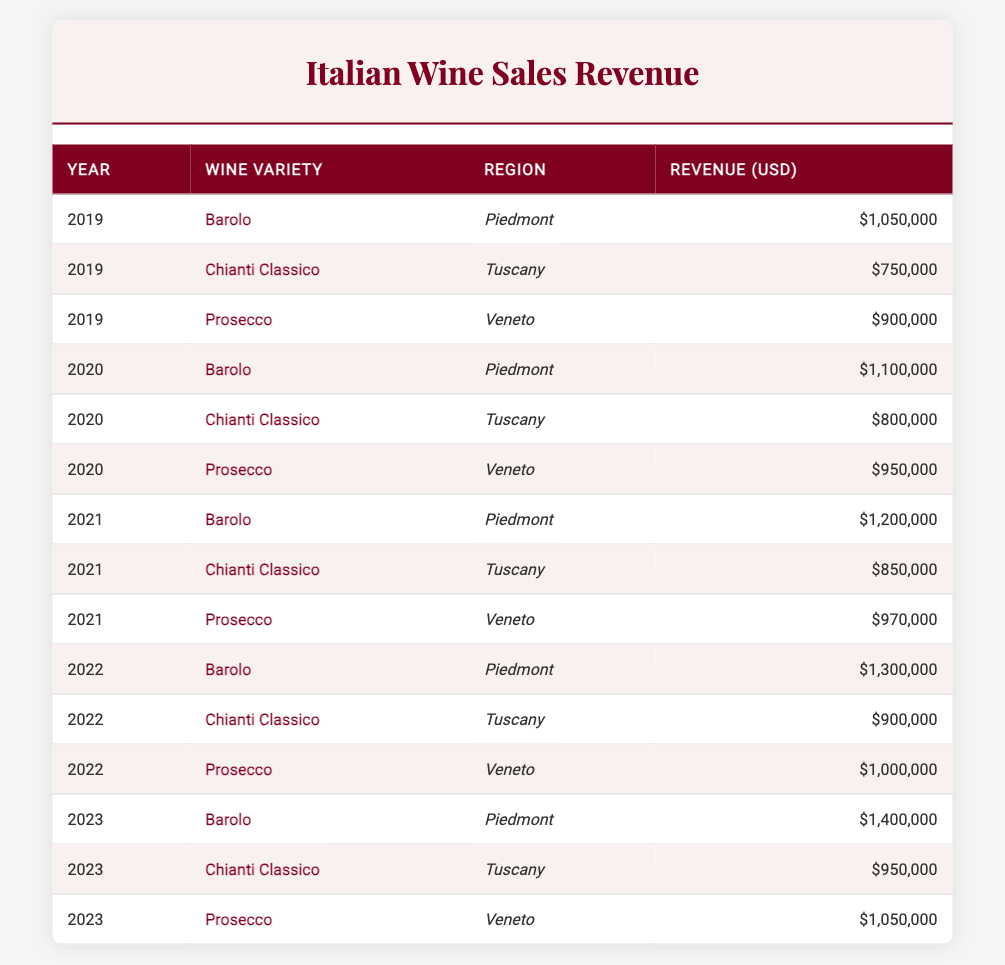What was the revenue for Barolo in 2022? From the table, I can find the row for Barolo in 2022, which shows the revenue as 1,300,000 USD.
Answer: 1,300,000 USD Which wine variety had the highest revenue in 2023? Looking at the 2023 data, Barolo has the highest revenue of 1,400,000 USD compared to Chianti Classico and Prosecco.
Answer: Barolo What is the total revenue generated by Prosecco over the past five years? I will sum the revenues for Prosecco from each year: 900,000 (2019) + 950,000 (2020) + 970,000 (2021) + 1,000,000 (2022) + 1,050,000 (2023). This totals to 4,870,000 USD.
Answer: 4,870,000 USD Did the revenue for Chianti Classico increase every year from 2019 to 2023? Evaluating the revenues year by year: 750,000 (2019), 800,000 (2020), 850,000 (2021), 900,000 (2022), 950,000 (2023). Since the revenue increased each year, the answer is yes.
Answer: Yes What is the average revenue of Barolo over the five years? The revenues for Barolo are: 1,050,000 (2019), 1,100,000 (2020), 1,200,000 (2021), 1,300,000 (2022), and 1,400,000 (2023). Summing these gives 5,050,000 USD. Dividing by 5 years results in an average of 1,010,000 USD.
Answer: 1,010,000 USD Was the revenue for Prosecco higher in 2023 than in 2019? Comparing the revenues, Prosecco earned 1,050,000 USD in 2023 and 900,000 USD in 2019. Since 1,050,000 is greater than 900,000, the statement is true.
Answer: Yes Which region consistently generated the highest revenue across all years? Checking the revenue for all regions: Piedmont for Barolo shows continual increases, reaching 1,400,000 USD in 2023. Other varieties in Tuscany and Veneto do not consistently match this revenue. Therefore, Piedmont consistently generated the highest revenue.
Answer: Piedmont How much more revenue did Barolo generate than Chianti Classico in 2021? For 2021, Barolo generated 1,200,000 USD while Chianti Classico generated 850,000 USD. The difference is calculated as 1,200,000 - 850,000 = 350,000 USD.
Answer: 350,000 USD 